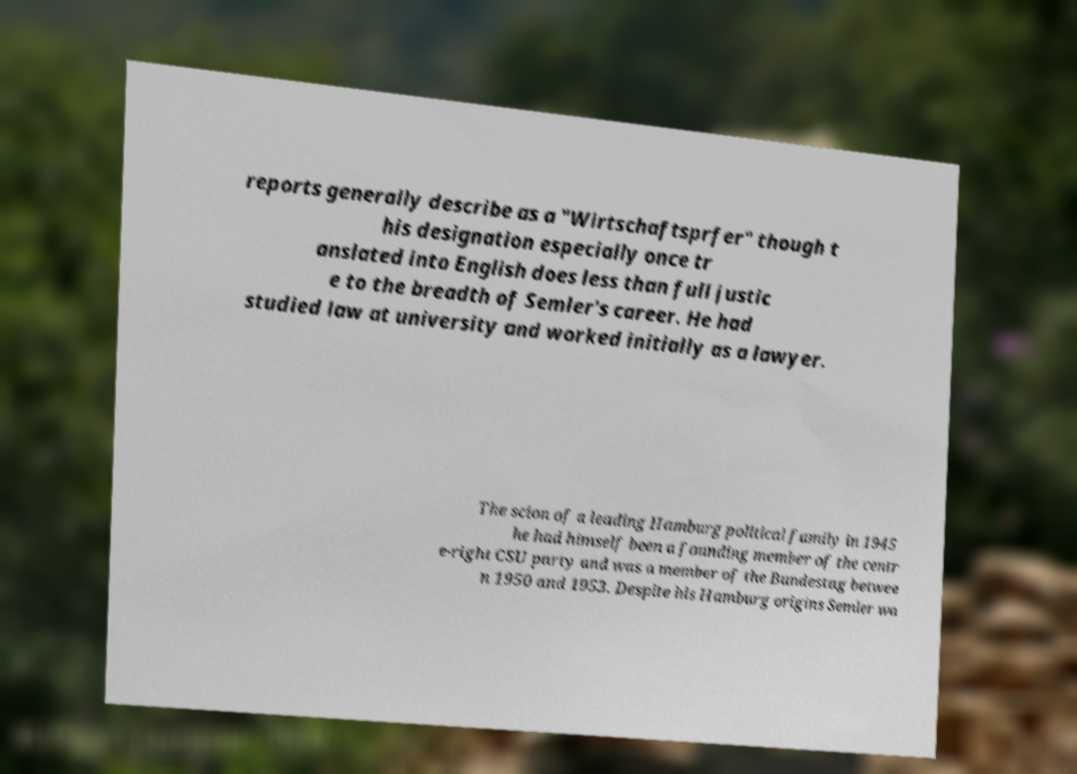Can you accurately transcribe the text from the provided image for me? reports generally describe as a "Wirtschaftsprfer" though t his designation especially once tr anslated into English does less than full justic e to the breadth of Semler's career. He had studied law at university and worked initially as a lawyer. The scion of a leading Hamburg political family in 1945 he had himself been a founding member of the centr e-right CSU party and was a member of the Bundestag betwee n 1950 and 1953. Despite his Hamburg origins Semler wa 